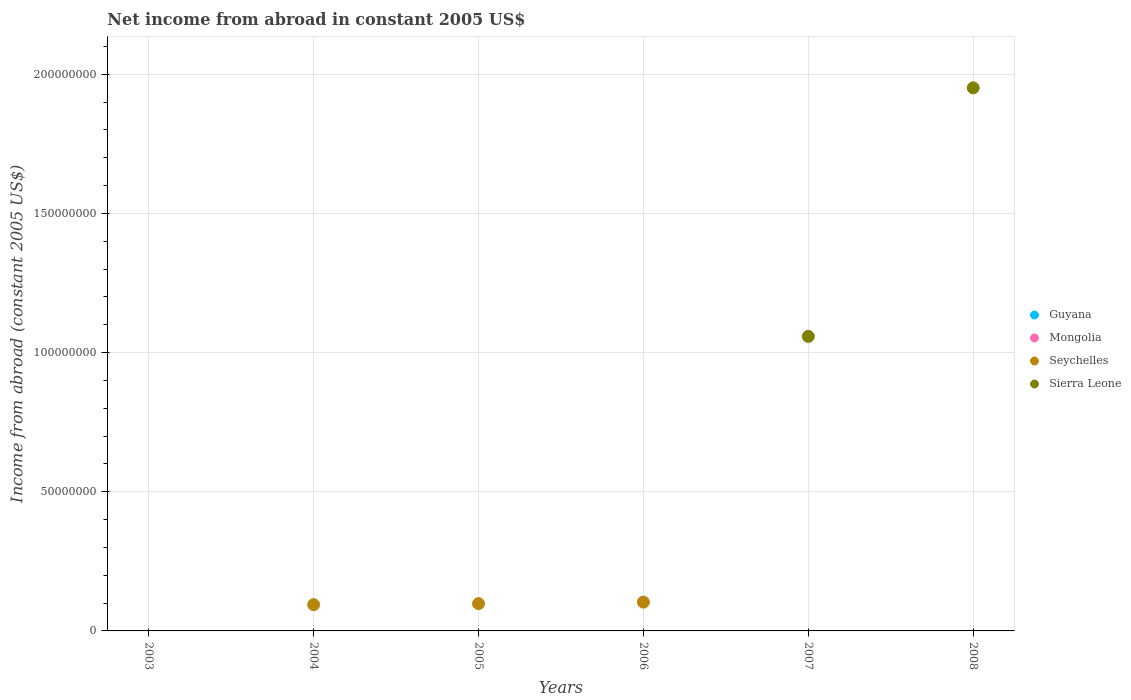Is the number of dotlines equal to the number of legend labels?
Your answer should be very brief. No. Across all years, what is the maximum net income from abroad in Sierra Leone?
Your response must be concise. 1.95e+08. In which year was the net income from abroad in Seychelles maximum?
Ensure brevity in your answer.  2006. What is the total net income from abroad in Seychelles in the graph?
Your answer should be compact. 2.96e+07. What is the difference between the net income from abroad in Sierra Leone in 2007 and that in 2008?
Your answer should be compact. -8.93e+07. What is the difference between the net income from abroad in Mongolia in 2004 and the net income from abroad in Seychelles in 2005?
Give a very brief answer. -9.81e+06. What is the average net income from abroad in Seychelles per year?
Provide a short and direct response. 4.93e+06. What is the difference between the highest and the second highest net income from abroad in Seychelles?
Make the answer very short. 5.42e+05. What is the difference between the highest and the lowest net income from abroad in Seychelles?
Offer a very short reply. 1.04e+07. Is it the case that in every year, the sum of the net income from abroad in Seychelles and net income from abroad in Guyana  is greater than the sum of net income from abroad in Sierra Leone and net income from abroad in Mongolia?
Provide a succinct answer. No. Is it the case that in every year, the sum of the net income from abroad in Guyana and net income from abroad in Mongolia  is greater than the net income from abroad in Sierra Leone?
Make the answer very short. No. Does the net income from abroad in Guyana monotonically increase over the years?
Give a very brief answer. No. Is the net income from abroad in Sierra Leone strictly less than the net income from abroad in Seychelles over the years?
Make the answer very short. No. How many years are there in the graph?
Give a very brief answer. 6. Are the values on the major ticks of Y-axis written in scientific E-notation?
Give a very brief answer. No. Does the graph contain grids?
Ensure brevity in your answer.  Yes. How many legend labels are there?
Give a very brief answer. 4. How are the legend labels stacked?
Keep it short and to the point. Vertical. What is the title of the graph?
Ensure brevity in your answer.  Net income from abroad in constant 2005 US$. Does "Micronesia" appear as one of the legend labels in the graph?
Make the answer very short. No. What is the label or title of the X-axis?
Your answer should be compact. Years. What is the label or title of the Y-axis?
Give a very brief answer. Income from abroad (constant 2005 US$). What is the Income from abroad (constant 2005 US$) in Guyana in 2003?
Offer a very short reply. 0. What is the Income from abroad (constant 2005 US$) of Mongolia in 2003?
Provide a short and direct response. 0. What is the Income from abroad (constant 2005 US$) in Seychelles in 2003?
Your answer should be very brief. 0. What is the Income from abroad (constant 2005 US$) of Sierra Leone in 2003?
Your response must be concise. 0. What is the Income from abroad (constant 2005 US$) of Mongolia in 2004?
Your response must be concise. 0. What is the Income from abroad (constant 2005 US$) of Seychelles in 2004?
Provide a succinct answer. 9.44e+06. What is the Income from abroad (constant 2005 US$) of Mongolia in 2005?
Keep it short and to the point. 0. What is the Income from abroad (constant 2005 US$) in Seychelles in 2005?
Your answer should be compact. 9.81e+06. What is the Income from abroad (constant 2005 US$) in Guyana in 2006?
Provide a succinct answer. 0. What is the Income from abroad (constant 2005 US$) in Mongolia in 2006?
Offer a terse response. 0. What is the Income from abroad (constant 2005 US$) in Seychelles in 2006?
Offer a terse response. 1.04e+07. What is the Income from abroad (constant 2005 US$) of Sierra Leone in 2006?
Keep it short and to the point. 0. What is the Income from abroad (constant 2005 US$) in Seychelles in 2007?
Your response must be concise. 0. What is the Income from abroad (constant 2005 US$) in Sierra Leone in 2007?
Keep it short and to the point. 1.06e+08. What is the Income from abroad (constant 2005 US$) in Guyana in 2008?
Keep it short and to the point. 0. What is the Income from abroad (constant 2005 US$) of Seychelles in 2008?
Give a very brief answer. 0. What is the Income from abroad (constant 2005 US$) in Sierra Leone in 2008?
Your answer should be compact. 1.95e+08. Across all years, what is the maximum Income from abroad (constant 2005 US$) in Seychelles?
Your response must be concise. 1.04e+07. Across all years, what is the maximum Income from abroad (constant 2005 US$) in Sierra Leone?
Ensure brevity in your answer.  1.95e+08. Across all years, what is the minimum Income from abroad (constant 2005 US$) in Seychelles?
Keep it short and to the point. 0. Across all years, what is the minimum Income from abroad (constant 2005 US$) in Sierra Leone?
Offer a terse response. 0. What is the total Income from abroad (constant 2005 US$) of Mongolia in the graph?
Ensure brevity in your answer.  0. What is the total Income from abroad (constant 2005 US$) of Seychelles in the graph?
Your answer should be very brief. 2.96e+07. What is the total Income from abroad (constant 2005 US$) of Sierra Leone in the graph?
Provide a short and direct response. 3.01e+08. What is the difference between the Income from abroad (constant 2005 US$) in Seychelles in 2004 and that in 2005?
Give a very brief answer. -3.71e+05. What is the difference between the Income from abroad (constant 2005 US$) in Seychelles in 2004 and that in 2006?
Offer a terse response. -9.14e+05. What is the difference between the Income from abroad (constant 2005 US$) in Seychelles in 2005 and that in 2006?
Your answer should be compact. -5.42e+05. What is the difference between the Income from abroad (constant 2005 US$) in Sierra Leone in 2007 and that in 2008?
Your answer should be compact. -8.93e+07. What is the difference between the Income from abroad (constant 2005 US$) of Seychelles in 2004 and the Income from abroad (constant 2005 US$) of Sierra Leone in 2007?
Make the answer very short. -9.64e+07. What is the difference between the Income from abroad (constant 2005 US$) of Seychelles in 2004 and the Income from abroad (constant 2005 US$) of Sierra Leone in 2008?
Your response must be concise. -1.86e+08. What is the difference between the Income from abroad (constant 2005 US$) of Seychelles in 2005 and the Income from abroad (constant 2005 US$) of Sierra Leone in 2007?
Your response must be concise. -9.60e+07. What is the difference between the Income from abroad (constant 2005 US$) of Seychelles in 2005 and the Income from abroad (constant 2005 US$) of Sierra Leone in 2008?
Offer a terse response. -1.85e+08. What is the difference between the Income from abroad (constant 2005 US$) of Seychelles in 2006 and the Income from abroad (constant 2005 US$) of Sierra Leone in 2007?
Your answer should be compact. -9.55e+07. What is the difference between the Income from abroad (constant 2005 US$) in Seychelles in 2006 and the Income from abroad (constant 2005 US$) in Sierra Leone in 2008?
Provide a short and direct response. -1.85e+08. What is the average Income from abroad (constant 2005 US$) of Guyana per year?
Provide a short and direct response. 0. What is the average Income from abroad (constant 2005 US$) of Seychelles per year?
Your answer should be very brief. 4.93e+06. What is the average Income from abroad (constant 2005 US$) in Sierra Leone per year?
Make the answer very short. 5.02e+07. What is the ratio of the Income from abroad (constant 2005 US$) of Seychelles in 2004 to that in 2005?
Your response must be concise. 0.96. What is the ratio of the Income from abroad (constant 2005 US$) in Seychelles in 2004 to that in 2006?
Provide a short and direct response. 0.91. What is the ratio of the Income from abroad (constant 2005 US$) of Seychelles in 2005 to that in 2006?
Make the answer very short. 0.95. What is the ratio of the Income from abroad (constant 2005 US$) in Sierra Leone in 2007 to that in 2008?
Give a very brief answer. 0.54. What is the difference between the highest and the second highest Income from abroad (constant 2005 US$) in Seychelles?
Offer a very short reply. 5.42e+05. What is the difference between the highest and the lowest Income from abroad (constant 2005 US$) of Seychelles?
Provide a succinct answer. 1.04e+07. What is the difference between the highest and the lowest Income from abroad (constant 2005 US$) in Sierra Leone?
Give a very brief answer. 1.95e+08. 